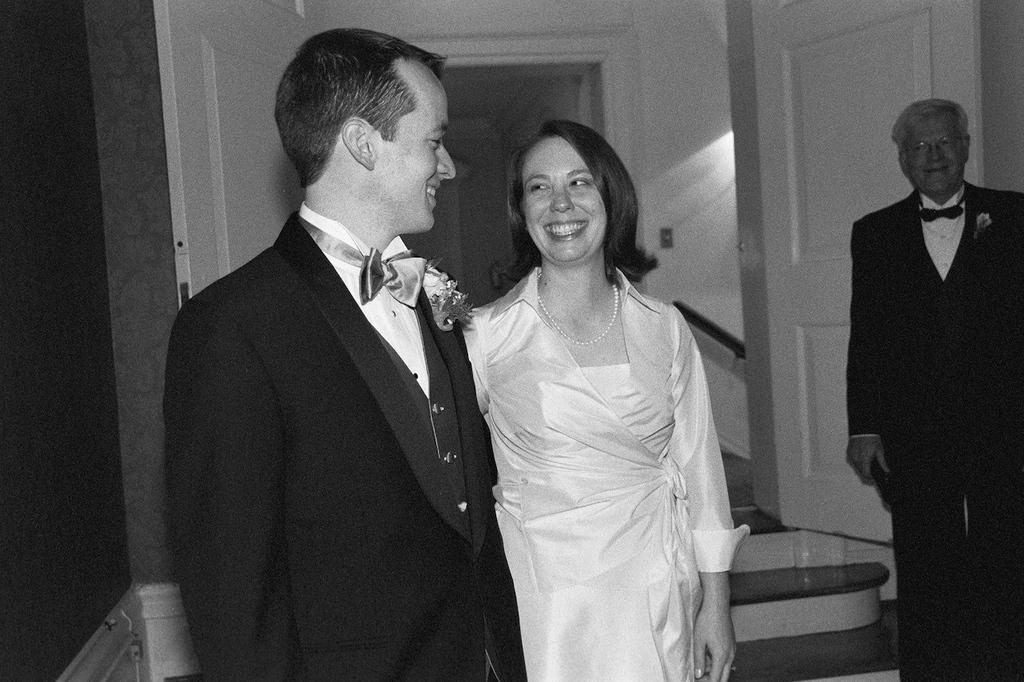How many people are present in the image? There are three people in the image. What expressions do the people have? The people are smiling. What can be seen in the background of the image? There is a wall and doors in the background of the image. Who is the owner of the bear in the image? There is no bear present in the image. 